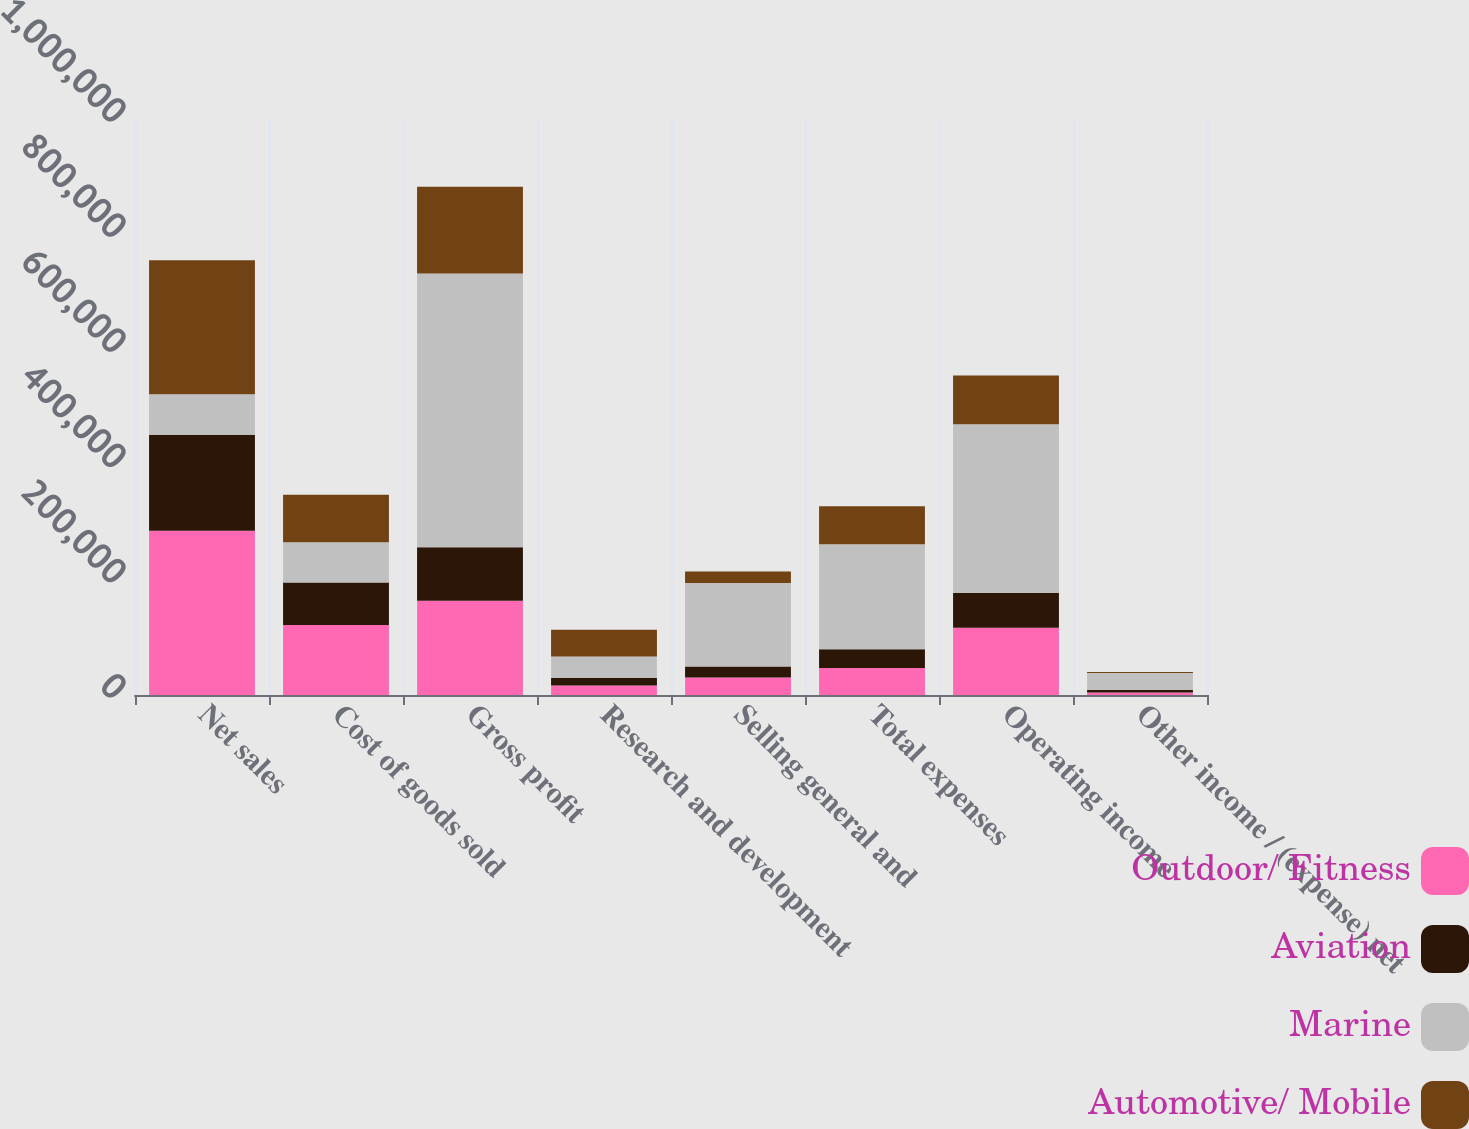<chart> <loc_0><loc_0><loc_500><loc_500><stacked_bar_chart><ecel><fcel>Net sales<fcel>Cost of goods sold<fcel>Gross profit<fcel>Research and development<fcel>Selling general and<fcel>Total expenses<fcel>Operating income<fcel>Other income / (expense) net<nl><fcel>Outdoor/ Fitness<fcel>285362<fcel>121724<fcel>163638<fcel>16697<fcel>30176<fcel>46873<fcel>116765<fcel>4140<nl><fcel>Aviation<fcel>166639<fcel>73687<fcel>92952<fcel>13121<fcel>19307<fcel>32428<fcel>60524<fcel>4563<nl><fcel>Marine<fcel>69987.5<fcel>69987.5<fcel>475191<fcel>37125<fcel>145113<fcel>182238<fcel>292953<fcel>29468<nl><fcel>Automotive/ Mobile<fcel>232906<fcel>82301<fcel>150605<fcel>46371<fcel>19917<fcel>66288<fcel>84317<fcel>1824<nl></chart> 